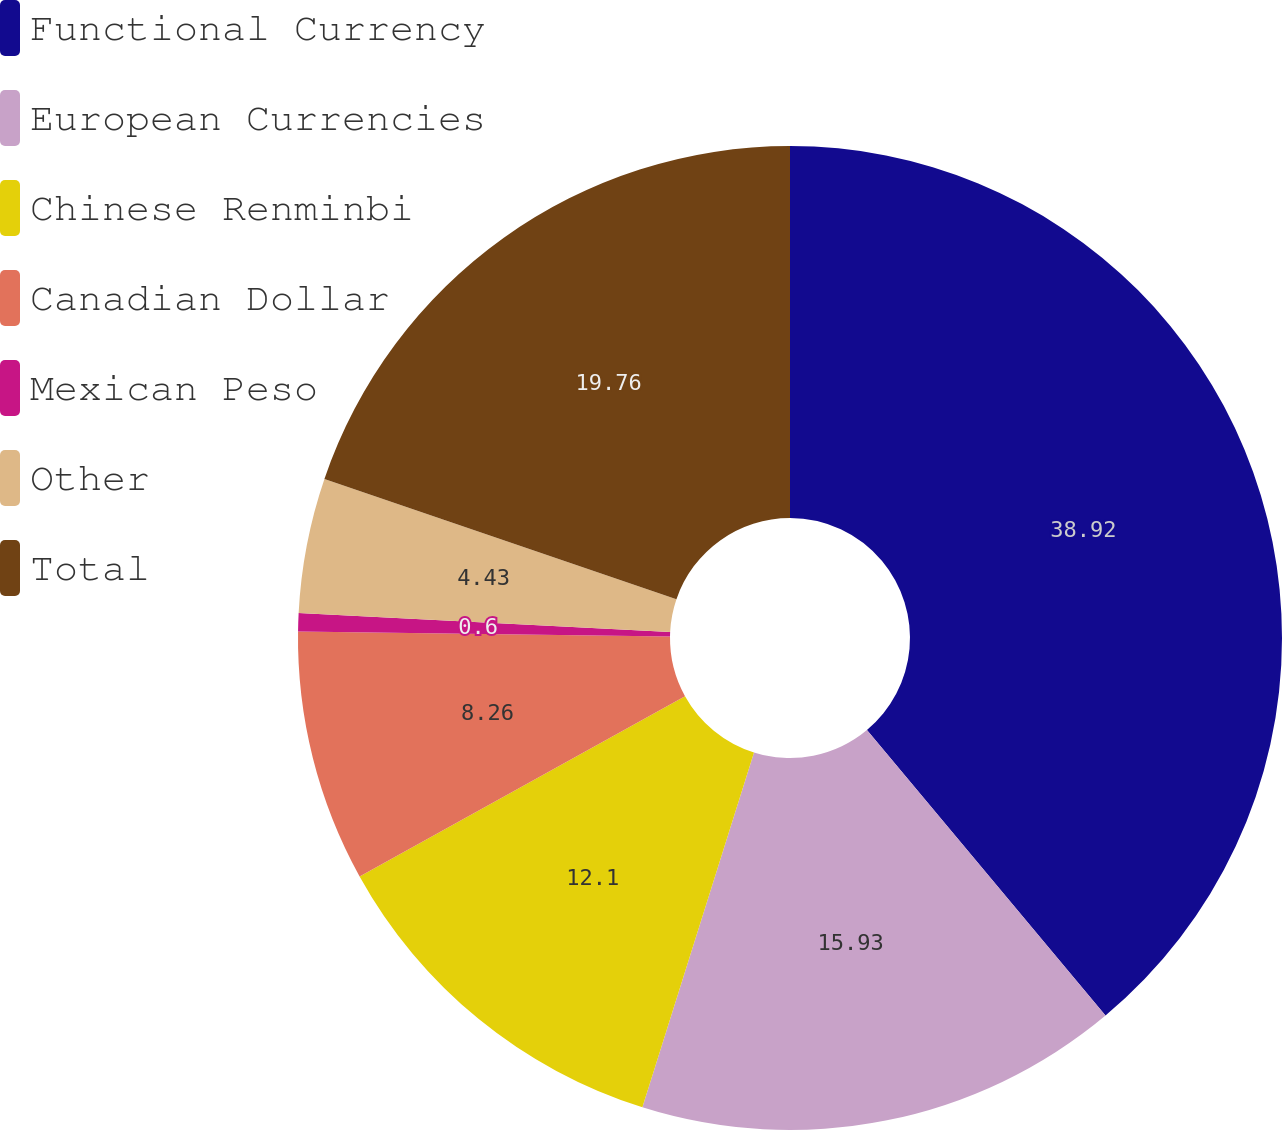Convert chart. <chart><loc_0><loc_0><loc_500><loc_500><pie_chart><fcel>Functional Currency<fcel>European Currencies<fcel>Chinese Renminbi<fcel>Canadian Dollar<fcel>Mexican Peso<fcel>Other<fcel>Total<nl><fcel>38.92%<fcel>15.93%<fcel>12.1%<fcel>8.26%<fcel>0.6%<fcel>4.43%<fcel>19.76%<nl></chart> 